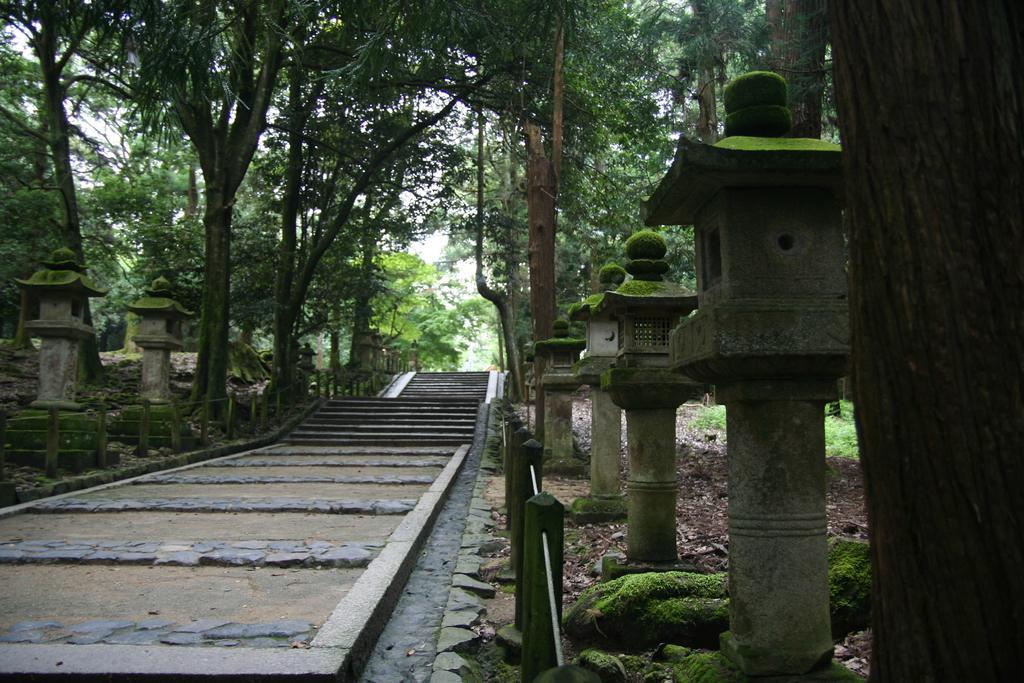Could you give a brief overview of what you see in this image? In this image, I can see a pathway with stairs. On the left and right side of the image, there are pillars, fence and trees. At the bottom right side of the image, I can see a tree trunk with algae. 